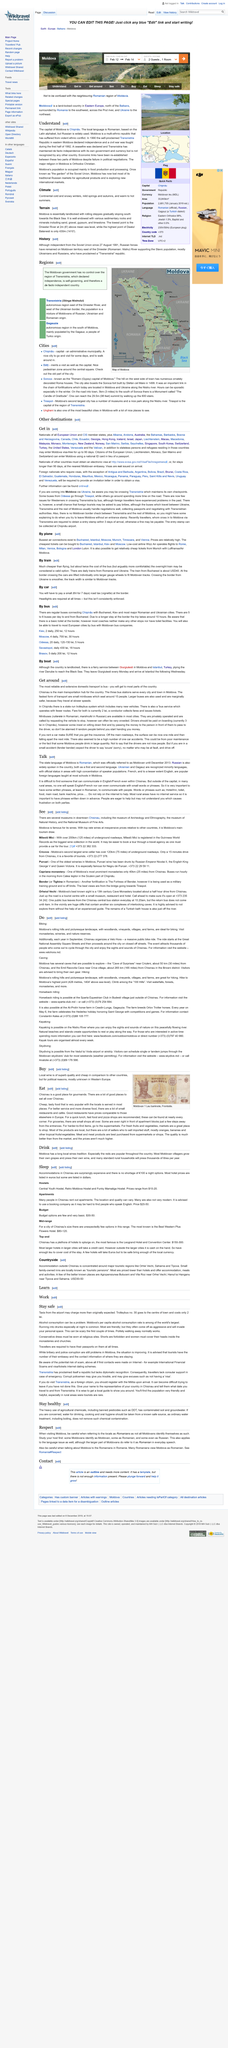Draw attention to some important aspects in this diagram. For a quick lunch, fast food and pizza shops are recommended as they provide quick and convenient options for dining. Many Romanians view Moldovans as also being Romanian. It is possible to call a minibus by requesting it to stop. The Emil Racovita Cave is approximately 265 kilometers (165 miles) from Chisinau, the capital city of Moldova. In Moldova, both caving and biking are available activities. 